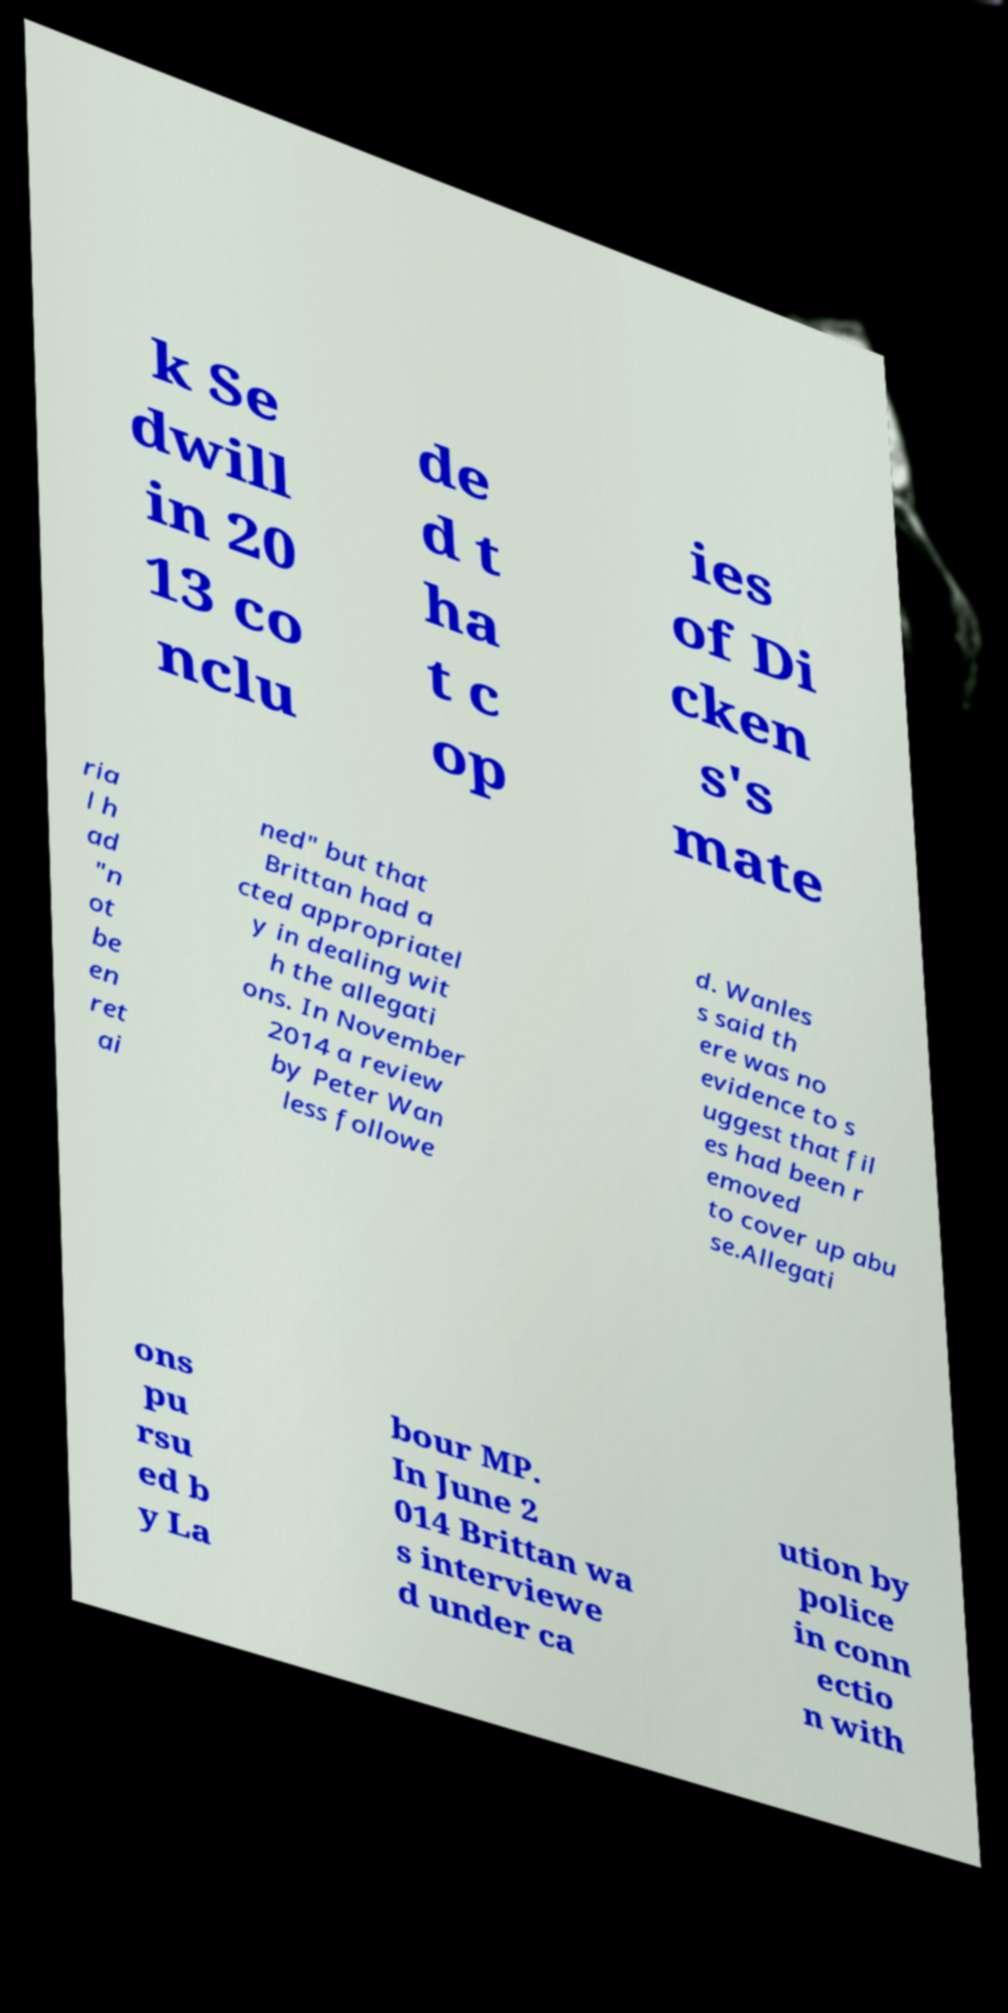I need the written content from this picture converted into text. Can you do that? k Se dwill in 20 13 co nclu de d t ha t c op ies of Di cken s's mate ria l h ad "n ot be en ret ai ned" but that Brittan had a cted appropriatel y in dealing wit h the allegati ons. In November 2014 a review by Peter Wan less followe d. Wanles s said th ere was no evidence to s uggest that fil es had been r emoved to cover up abu se.Allegati ons pu rsu ed b y La bour MP. In June 2 014 Brittan wa s interviewe d under ca ution by police in conn ectio n with 